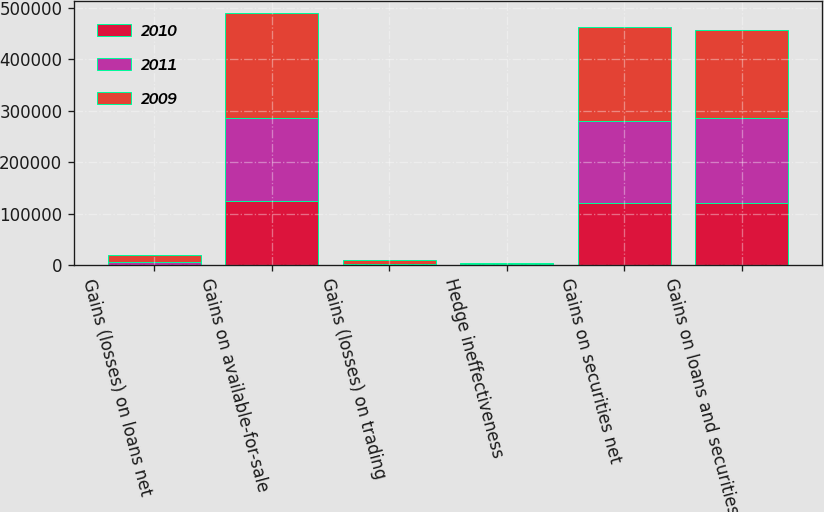Convert chart to OTSL. <chart><loc_0><loc_0><loc_500><loc_500><stacked_bar_chart><ecel><fcel>Gains (losses) on loans net<fcel>Gains on available-for-sale<fcel>Gains (losses) on trading<fcel>Hedge ineffectiveness<fcel>Gains on securities net<fcel>Gains on loans and securities<nl><fcel>2010<fcel>146<fcel>124360<fcel>1883<fcel>2390<fcel>120087<fcel>120233<nl><fcel>2011<fcel>6266<fcel>160952<fcel>162<fcel>981<fcel>159946<fcel>166212<nl><fcel>2009<fcel>12496<fcel>203619<fcel>7845<fcel>579<fcel>181602<fcel>169106<nl></chart> 